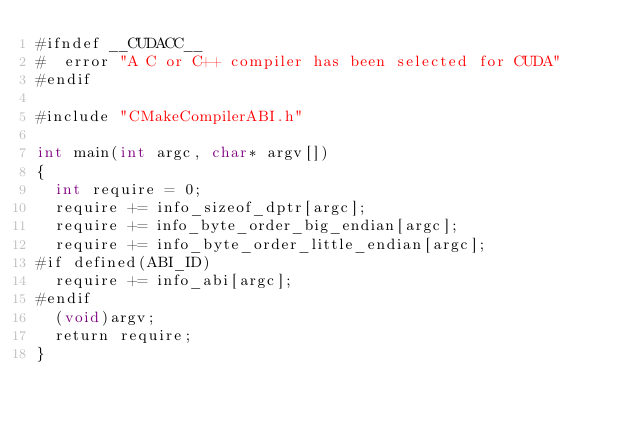Convert code to text. <code><loc_0><loc_0><loc_500><loc_500><_Cuda_>#ifndef __CUDACC__
#  error "A C or C++ compiler has been selected for CUDA"
#endif

#include "CMakeCompilerABI.h"

int main(int argc, char* argv[])
{
  int require = 0;
  require += info_sizeof_dptr[argc];
  require += info_byte_order_big_endian[argc];
  require += info_byte_order_little_endian[argc];
#if defined(ABI_ID)
  require += info_abi[argc];
#endif
  (void)argv;
  return require;
}
</code> 